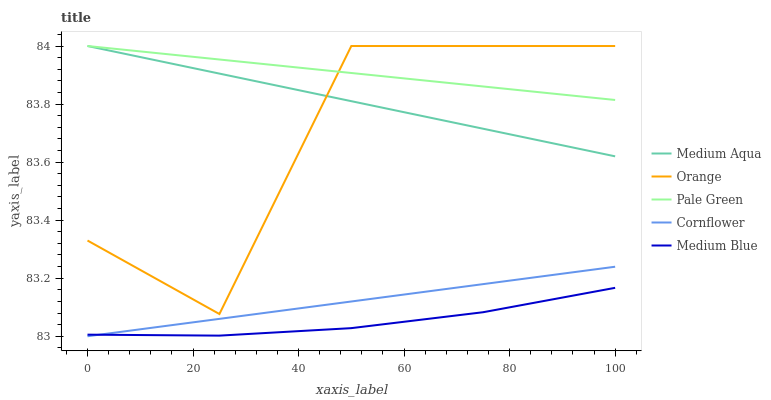Does Medium Blue have the minimum area under the curve?
Answer yes or no. Yes. Does Pale Green have the maximum area under the curve?
Answer yes or no. Yes. Does Cornflower have the minimum area under the curve?
Answer yes or no. No. Does Cornflower have the maximum area under the curve?
Answer yes or no. No. Is Pale Green the smoothest?
Answer yes or no. Yes. Is Orange the roughest?
Answer yes or no. Yes. Is Cornflower the smoothest?
Answer yes or no. No. Is Cornflower the roughest?
Answer yes or no. No. Does Cornflower have the lowest value?
Answer yes or no. Yes. Does Pale Green have the lowest value?
Answer yes or no. No. Does Medium Aqua have the highest value?
Answer yes or no. Yes. Does Cornflower have the highest value?
Answer yes or no. No. Is Cornflower less than Medium Aqua?
Answer yes or no. Yes. Is Medium Aqua greater than Cornflower?
Answer yes or no. Yes. Does Orange intersect Pale Green?
Answer yes or no. Yes. Is Orange less than Pale Green?
Answer yes or no. No. Is Orange greater than Pale Green?
Answer yes or no. No. Does Cornflower intersect Medium Aqua?
Answer yes or no. No. 